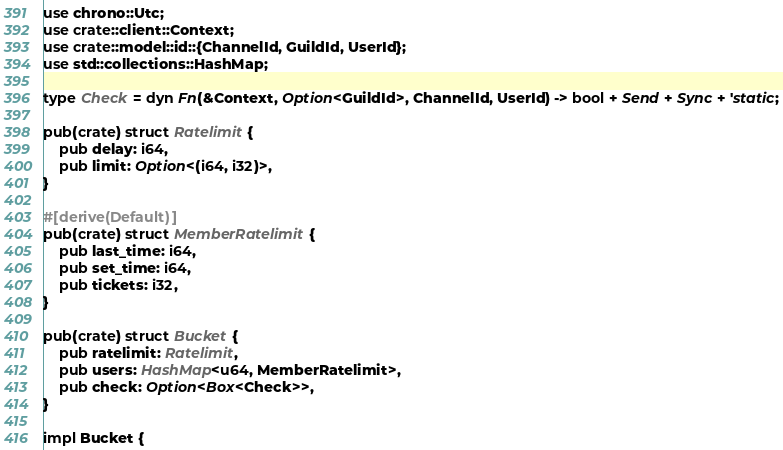<code> <loc_0><loc_0><loc_500><loc_500><_Rust_>use chrono::Utc;
use crate::client::Context;
use crate::model::id::{ChannelId, GuildId, UserId};
use std::collections::HashMap;

type Check = dyn Fn(&Context, Option<GuildId>, ChannelId, UserId) -> bool + Send + Sync + 'static;

pub(crate) struct Ratelimit {
    pub delay: i64,
    pub limit: Option<(i64, i32)>,
}

#[derive(Default)]
pub(crate) struct MemberRatelimit {
    pub last_time: i64,
    pub set_time: i64,
    pub tickets: i32,
}

pub(crate) struct Bucket {
    pub ratelimit: Ratelimit,
    pub users: HashMap<u64, MemberRatelimit>,
    pub check: Option<Box<Check>>,
}

impl Bucket {</code> 